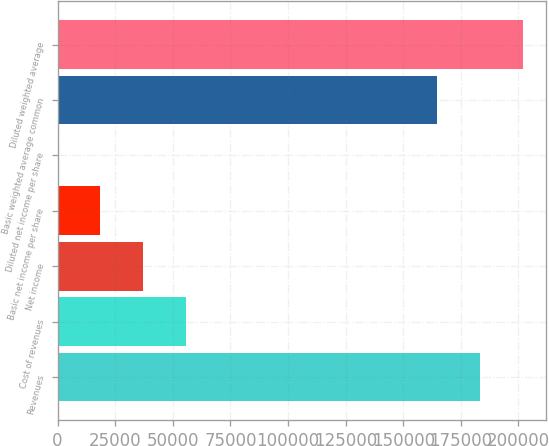Convert chart. <chart><loc_0><loc_0><loc_500><loc_500><bar_chart><fcel>Revenues<fcel>Cost of revenues<fcel>Net income<fcel>Basic net income per share<fcel>Diluted net income per share<fcel>Basic weighted average common<fcel>Diluted weighted average<nl><fcel>183297<fcel>55588.3<fcel>37059<fcel>18529.6<fcel>0.2<fcel>164768<fcel>201827<nl></chart> 